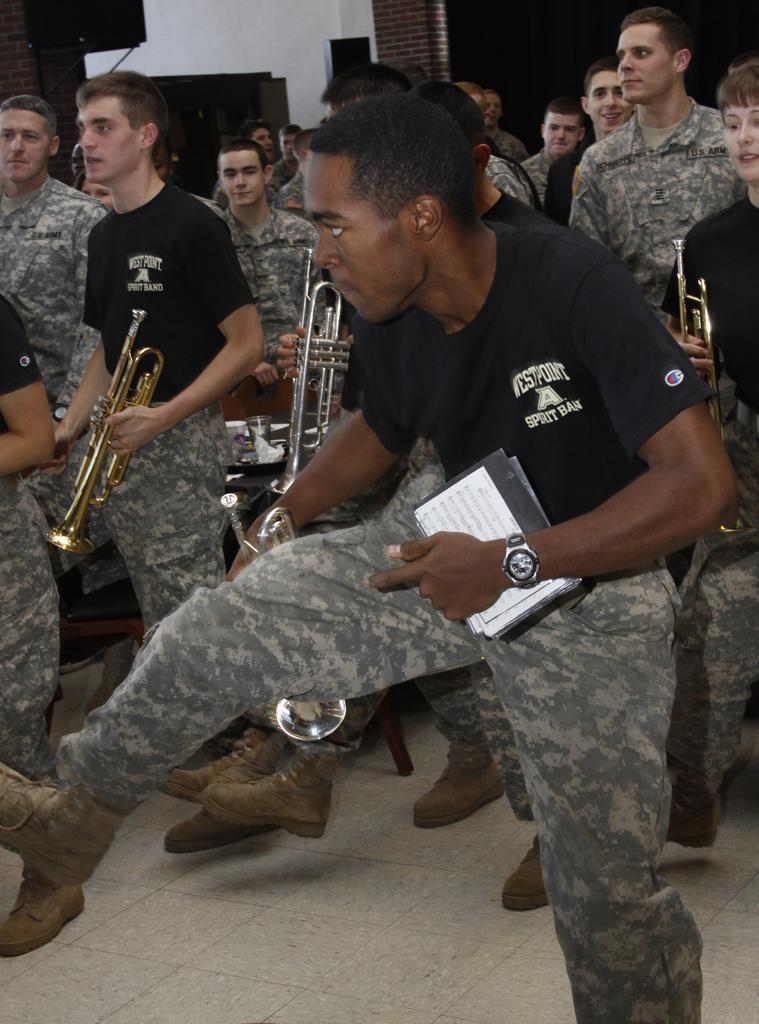What are the people in the image doing? The people in the image are holding musical instruments. What can be seen in the background of the image? There is a loudspeaker, a wall, and televisions in the background of the image. What type of chalk is being used to draw on the wall in the image? There is no chalk or drawing on the wall in the image. Can you see any monkeys playing musical instruments in the image? There are no monkeys present in the image; only people are holding musical instruments. 